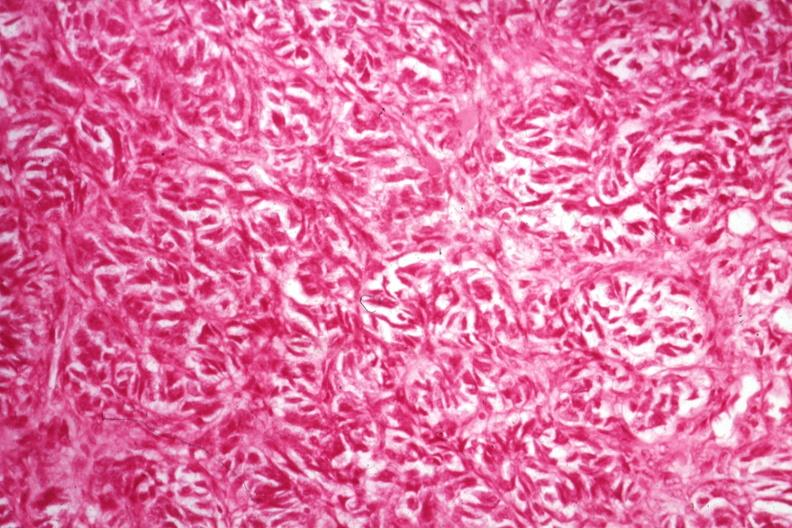what is present?
Answer the question using a single word or phrase. Female reproductive 